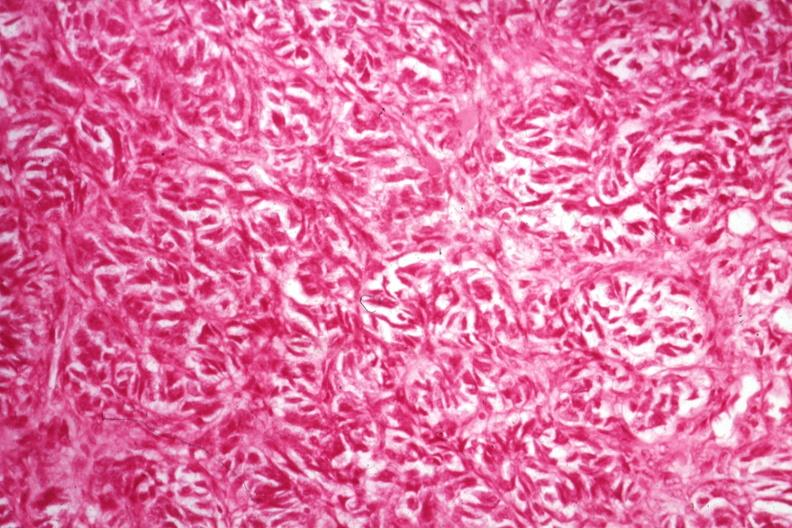what is present?
Answer the question using a single word or phrase. Female reproductive 